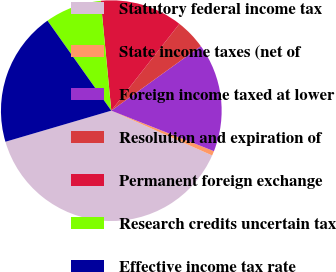Convert chart. <chart><loc_0><loc_0><loc_500><loc_500><pie_chart><fcel>Statutory federal income tax<fcel>State income taxes (net of<fcel>Foreign income taxed at lower<fcel>Resolution and expiration of<fcel>Permanent foreign exchange<fcel>Research credits uncertain tax<fcel>Effective income tax rate<nl><fcel>38.8%<fcel>0.67%<fcel>15.92%<fcel>4.48%<fcel>12.11%<fcel>8.29%<fcel>19.73%<nl></chart> 